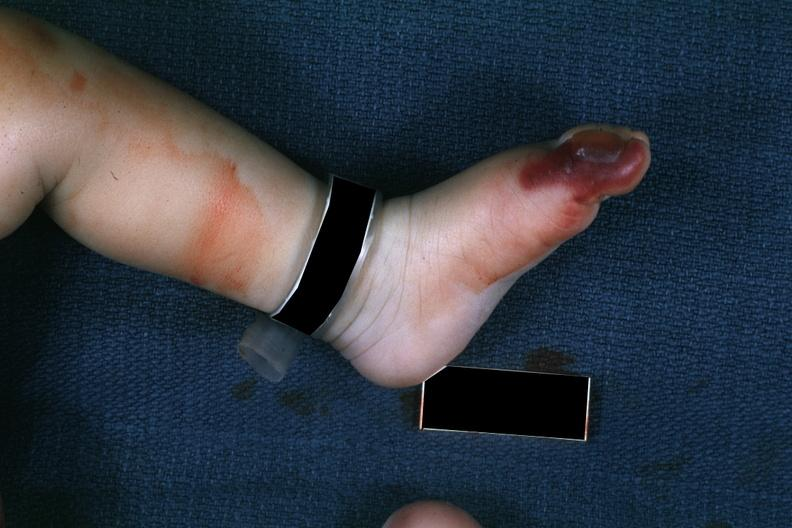what is present?
Answer the question using a single word or phrase. Gangrene toe in infant 